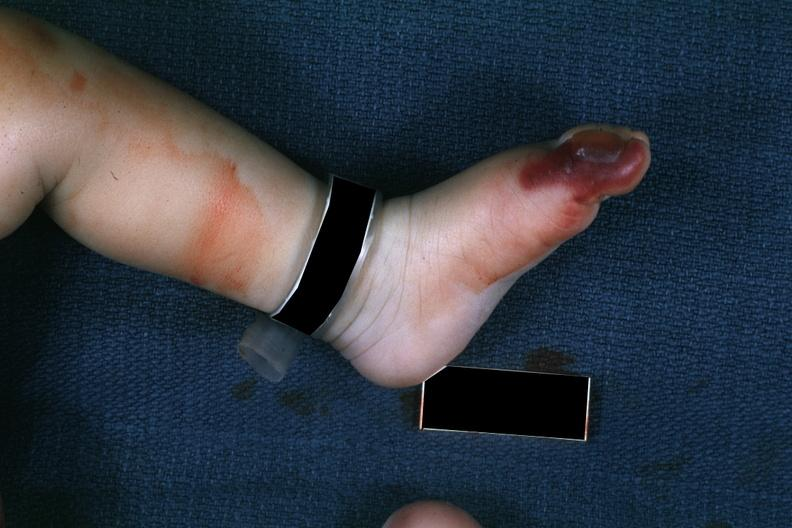what is present?
Answer the question using a single word or phrase. Gangrene toe in infant 